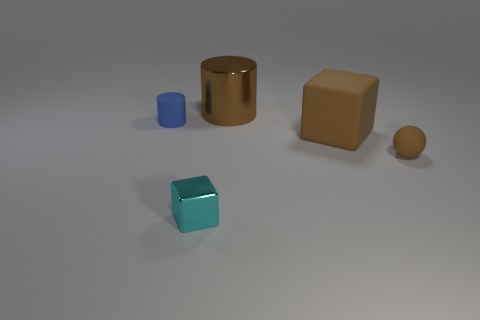Are there the same number of brown cylinders in front of the blue rubber thing and small metallic cubes?
Offer a terse response. No. The brown ball is what size?
Provide a short and direct response. Small. There is a tiny thing that is the same color as the large shiny cylinder; what is it made of?
Provide a succinct answer. Rubber. How many tiny blocks are the same color as the big cylinder?
Give a very brief answer. 0. Do the brown metal object and the brown matte ball have the same size?
Give a very brief answer. No. There is a brown object that is behind the brown matte thing that is to the left of the tiny brown thing; what is its size?
Ensure brevity in your answer.  Large. There is a shiny cube; is it the same color as the big thing in front of the small cylinder?
Keep it short and to the point. No. Are there any rubber things that have the same size as the cyan shiny block?
Provide a short and direct response. Yes. There is a object that is in front of the tiny brown rubber ball; how big is it?
Offer a very short reply. Small. There is a tiny rubber thing that is to the right of the brown cylinder; are there any tiny cyan metallic blocks in front of it?
Your response must be concise. Yes. 